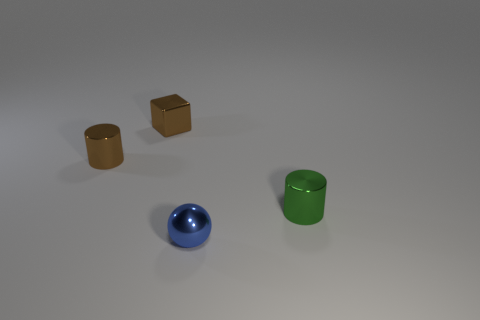What is the object that is behind the thing on the left side of the brown block made of?
Give a very brief answer. Metal. Is the color of the metal cylinder that is left of the tiny blue metallic object the same as the metal cube?
Ensure brevity in your answer.  Yes. Is there any other thing that has the same material as the green object?
Your answer should be compact. Yes. What number of blue things have the same shape as the small green object?
Ensure brevity in your answer.  0. There is a green cylinder that is made of the same material as the sphere; what is its size?
Your answer should be very brief. Small. Are there any small blue metal balls that are behind the tiny blue shiny ball in front of the shiny cylinder that is behind the green object?
Ensure brevity in your answer.  No. Do the brown shiny thing to the left of the cube and the tiny metallic sphere have the same size?
Your answer should be compact. Yes. How many green cylinders are the same size as the blue metallic object?
Make the answer very short. 1. What size is the object that is the same color as the shiny block?
Provide a short and direct response. Small. Is the color of the tiny block the same as the metal ball?
Provide a succinct answer. No. 